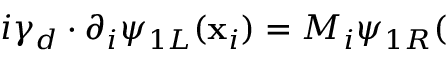<formula> <loc_0><loc_0><loc_500><loc_500>i \gamma _ { d } \cdot \partial _ { i } \psi _ { 1 L } ( x _ { i } ) = M _ { i } \psi _ { 1 R } (</formula> 